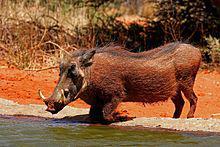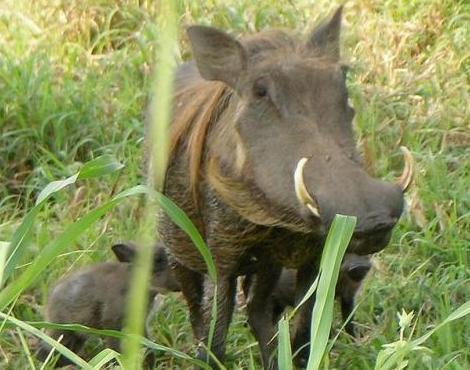The first image is the image on the left, the second image is the image on the right. Analyze the images presented: Is the assertion "An image contains both juvenile and adult warthogs, and features small animals standing by a taller animal." valid? Answer yes or no. Yes. The first image is the image on the left, the second image is the image on the right. For the images shown, is this caption "There are more than one animals in on of the images." true? Answer yes or no. Yes. 